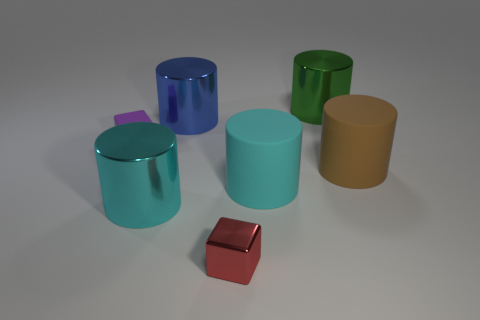Subtract all cyan matte cylinders. How many cylinders are left? 4 Subtract all red cylinders. Subtract all purple cubes. How many cylinders are left? 5 Add 1 purple objects. How many objects exist? 8 Subtract all blocks. How many objects are left? 5 Add 3 green metallic cylinders. How many green metallic cylinders are left? 4 Add 6 large brown metallic blocks. How many large brown metallic blocks exist? 6 Subtract 0 red cylinders. How many objects are left? 7 Subtract all brown spheres. Subtract all big cyan rubber cylinders. How many objects are left? 6 